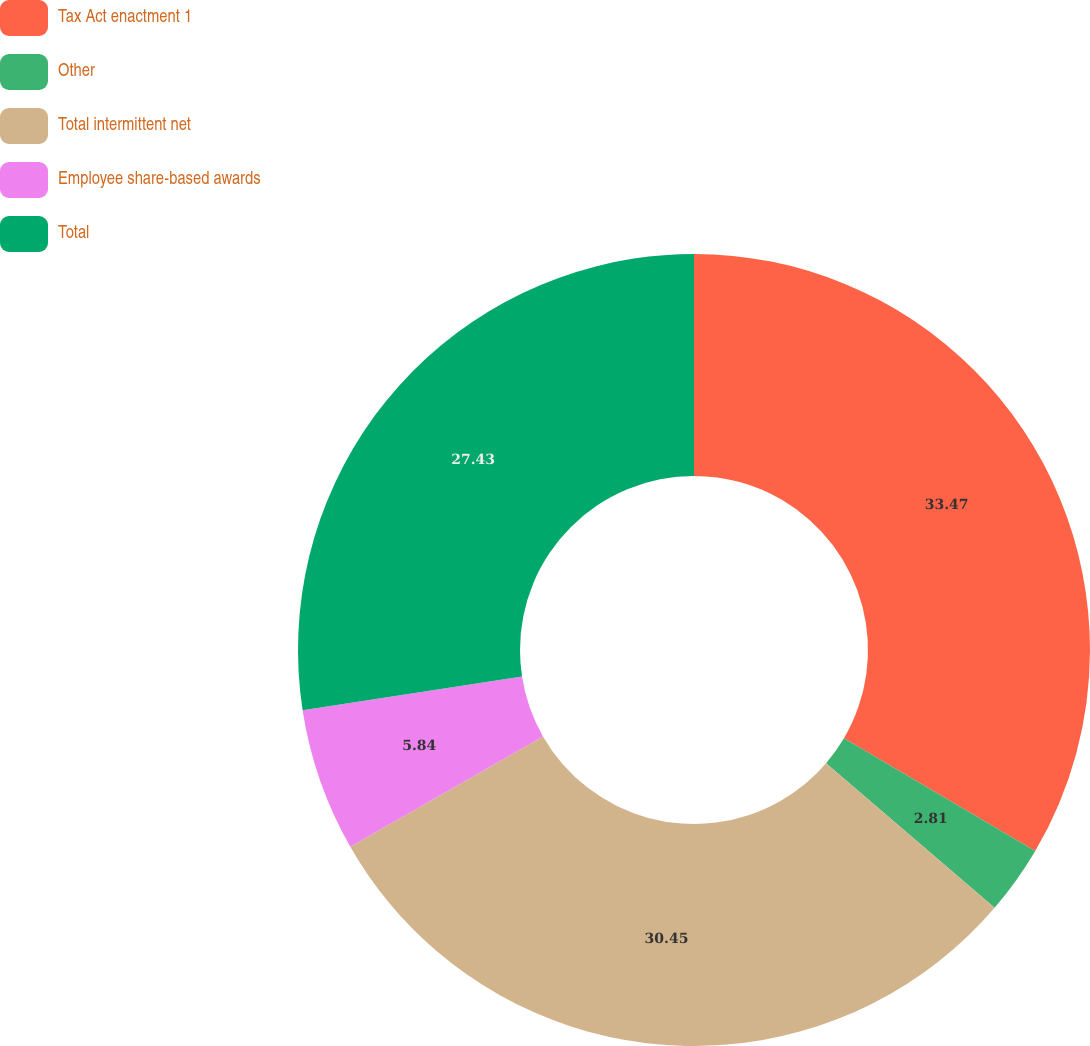Convert chart to OTSL. <chart><loc_0><loc_0><loc_500><loc_500><pie_chart><fcel>Tax Act enactment 1<fcel>Other<fcel>Total intermittent net<fcel>Employee share-based awards<fcel>Total<nl><fcel>33.47%<fcel>2.81%<fcel>30.45%<fcel>5.84%<fcel>27.43%<nl></chart> 